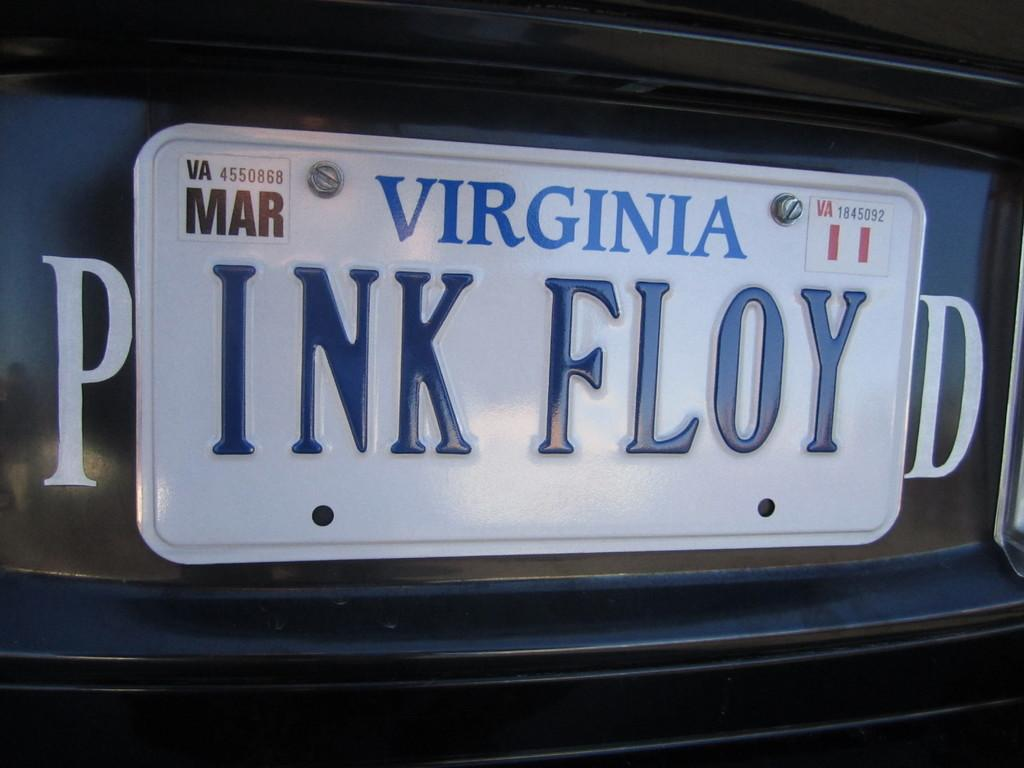<image>
Describe the image concisely. A Virginia Licence plate is cleverly constructed to read Pink Floyd. 